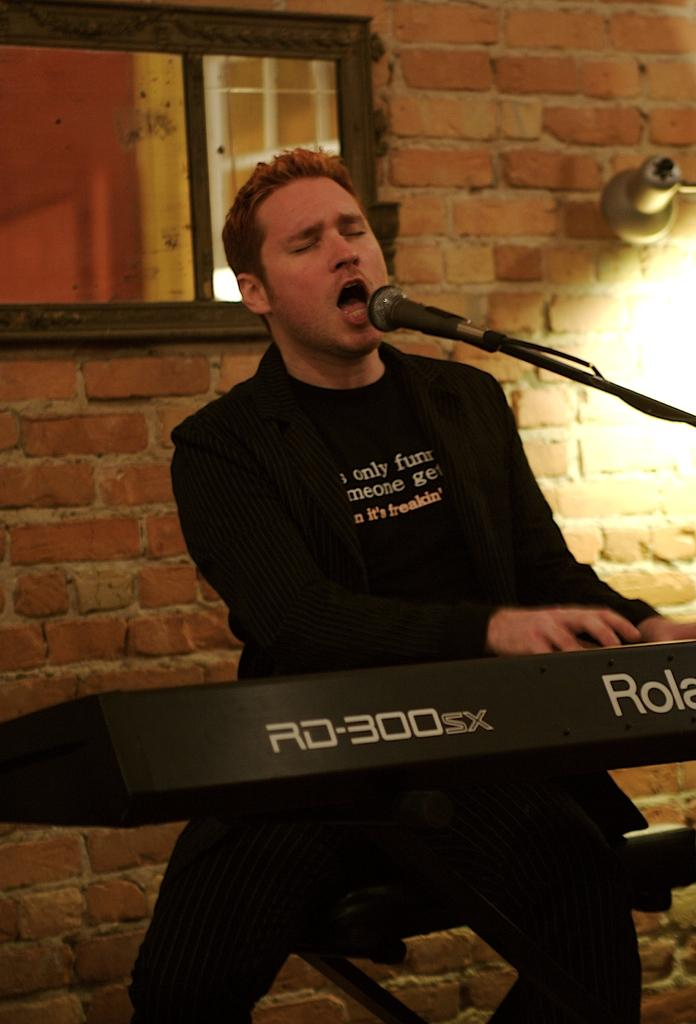What is the main subject of the image? There is a person in the middle of the image. What is the person holding in the image? The person is holding a microphone (mike) in the image. What can be seen in front of the person? There is a musical instrument in front of the person. What is visible in the background of the image? There is a window and a wall in the background of the image. Where is the light located in the image? The light is on the right side of the image. How many fairies are dancing on the window in the image? There are no fairies present in the image, and therefore no such activity can be observed. 